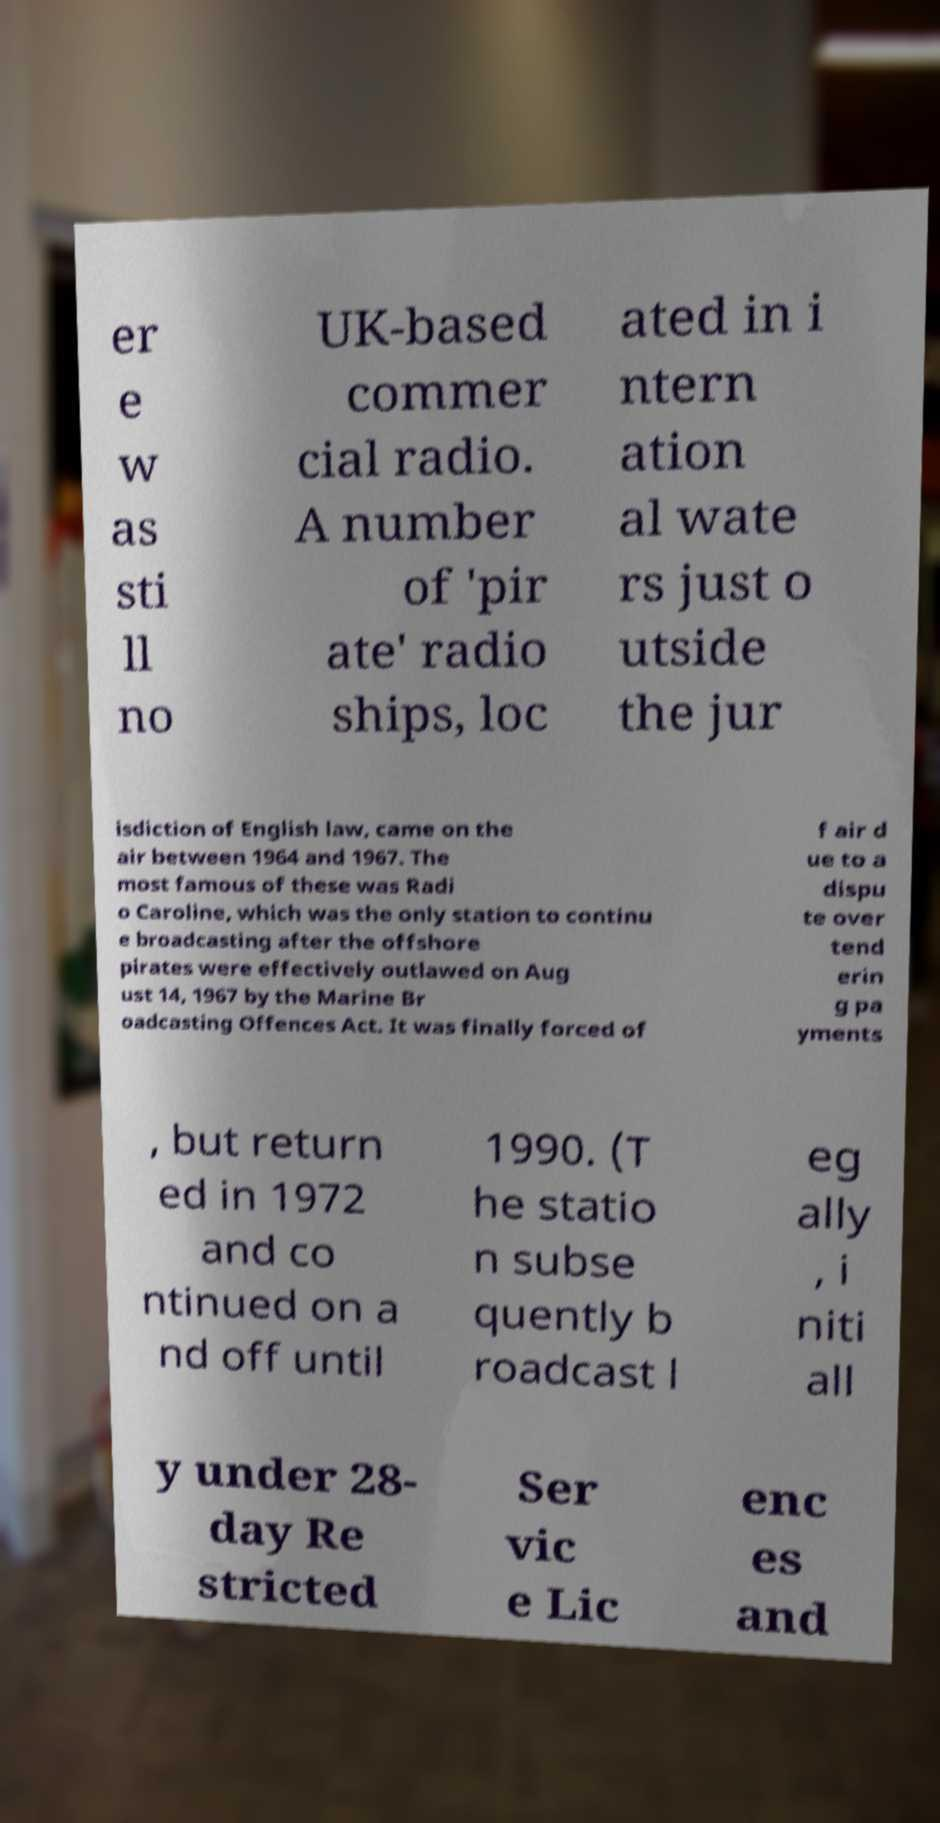Could you assist in decoding the text presented in this image and type it out clearly? er e w as sti ll no UK-based commer cial radio. A number of 'pir ate' radio ships, loc ated in i ntern ation al wate rs just o utside the jur isdiction of English law, came on the air between 1964 and 1967. The most famous of these was Radi o Caroline, which was the only station to continu e broadcasting after the offshore pirates were effectively outlawed on Aug ust 14, 1967 by the Marine Br oadcasting Offences Act. It was finally forced of f air d ue to a dispu te over tend erin g pa yments , but return ed in 1972 and co ntinued on a nd off until 1990. (T he statio n subse quently b roadcast l eg ally , i niti all y under 28- day Re stricted Ser vic e Lic enc es and 